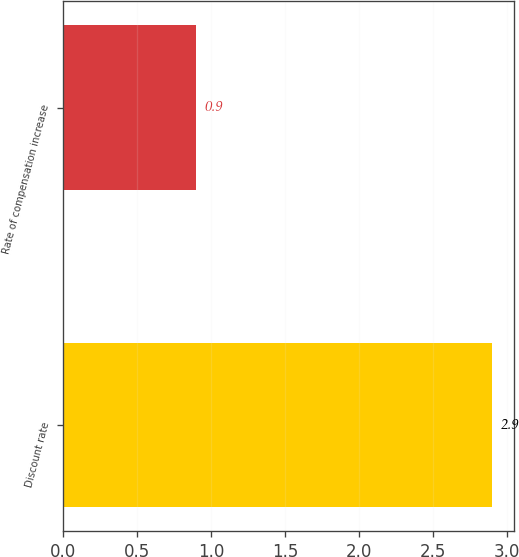<chart> <loc_0><loc_0><loc_500><loc_500><bar_chart><fcel>Discount rate<fcel>Rate of compensation increase<nl><fcel>2.9<fcel>0.9<nl></chart> 